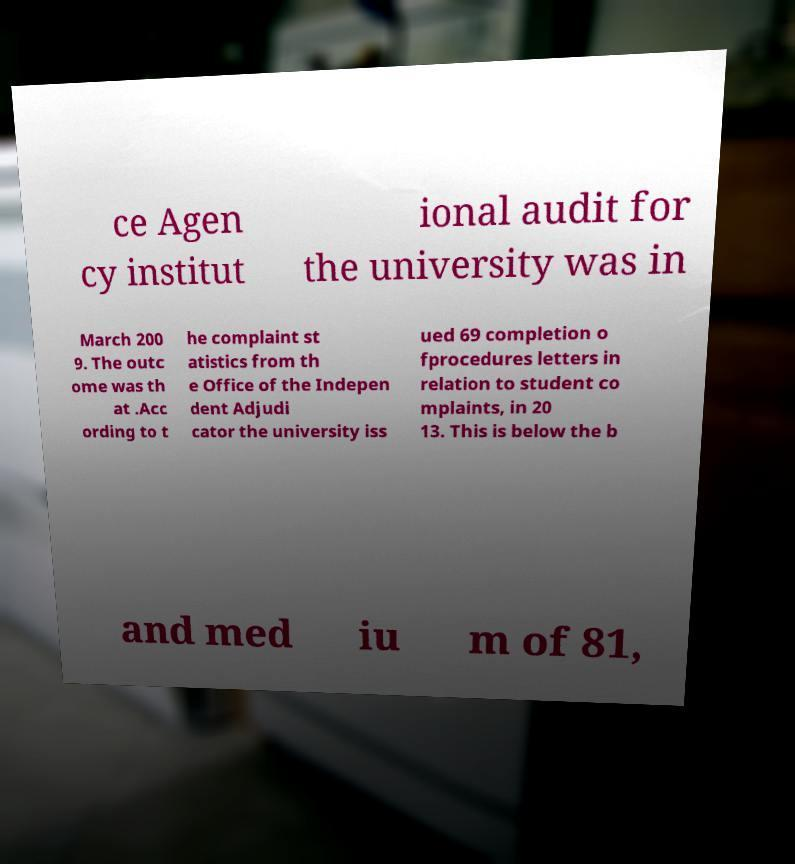For documentation purposes, I need the text within this image transcribed. Could you provide that? ce Agen cy institut ional audit for the university was in March 200 9. The outc ome was th at .Acc ording to t he complaint st atistics from th e Office of the Indepen dent Adjudi cator the university iss ued 69 completion o fprocedures letters in relation to student co mplaints, in 20 13. This is below the b and med iu m of 81, 